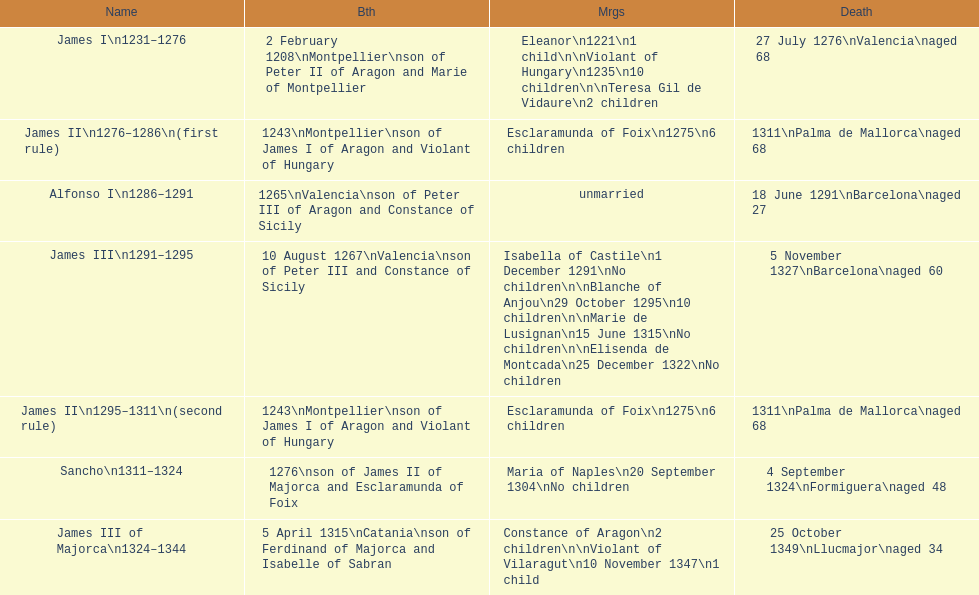How long was james ii in power, including his second rule? 26 years. 